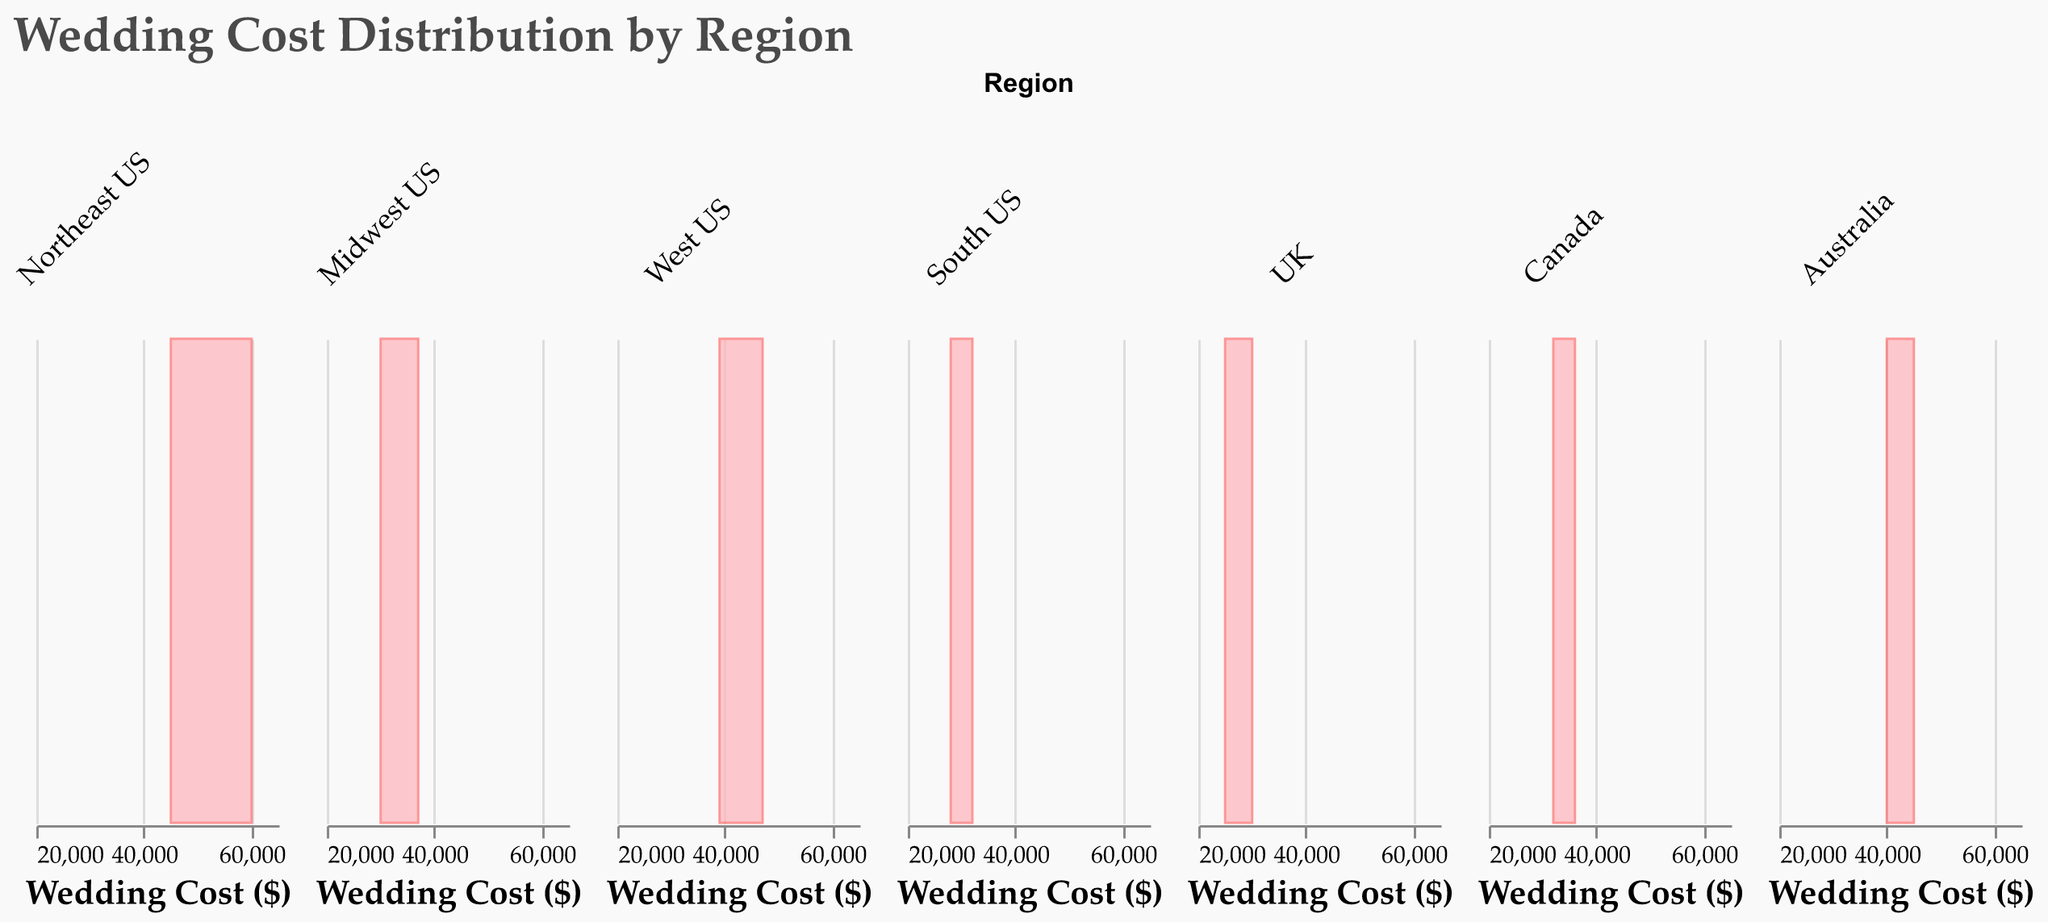What is the title of the figure? The title of the figure is located at the top of the plot and reads "Wedding Cost Distribution by Region".
Answer: Wedding Cost Distribution by Region Which region has the highest recorded wedding cost? By examining the x-axis scales across the subplots, the highest wedding cost belongs to the "Northeast US" region, with a cost of $60,000.
Answer: Northeast US What's the color used to fill the density plots? The density plots are filled with a pale pink color. This can be deduced from the color description "#ffb3ba" mentioned in the figure details.
Answer: Pale pink How many unique regions are displayed in the figure? By counting the facets (subplots) and the region labels underneath each subplot, you can see there are 7 unique regions displayed (Northeast US, Midwest US, West US, South US, UK, Canada, Australia).
Answer: 7 What is the range of wedding costs for the Australia region? The x-axis scales for the Australia region display a range of costs from $40,000 to $45,000.
Answer: $40,000 to $45,000 Which region has the lowest range in wedding costs? By comparing the density plots, the region with the lowest range in wedding costs is the UK, with costs ranging approximately between $25,000 and $30,000.
Answer: UK Between "Midwest US" and "Canada," which region has higher wedding costs on average? To compare, observe the central tendency (peak) of the density plots. The "Midwest US" costs average around $34,000-35,000, while "Canada" costs average around $34,000-35,000 as well. They are quite similar in average cost.
Answer: Similar What's the common wedding cost range for the "South US"? Observing the density peaks, the common wedding cost range for the "South US" is between $28,000 and $32,000.
Answer: $28,000 to $32,000 Is the density plot distribution symmetric for "Northeast US"? By visually examining the plot, the distribution for "Northeast US" appears moderately right-skewed, not symmetric.
Answer: No 